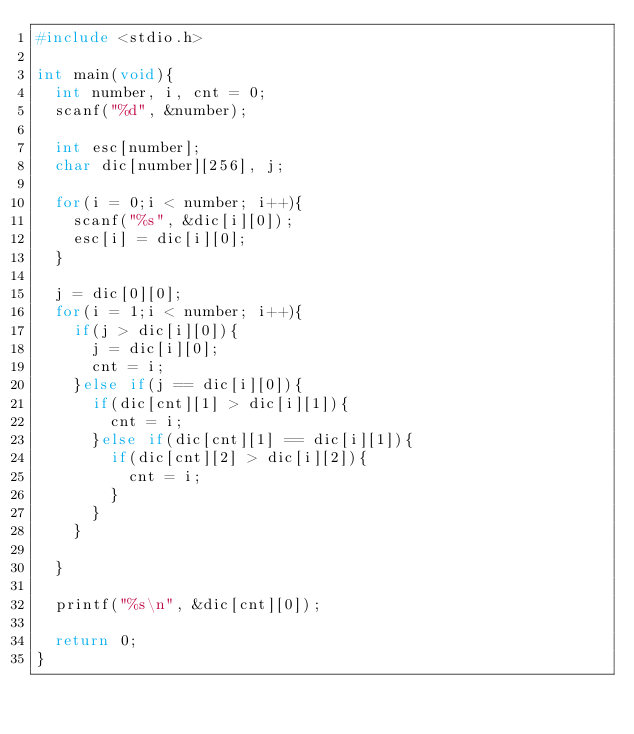Convert code to text. <code><loc_0><loc_0><loc_500><loc_500><_C_>#include <stdio.h>

int main(void){
	int number, i, cnt = 0;
	scanf("%d", &number);

	int esc[number];
	char dic[number][256], j;

	for(i = 0;i < number; i++){
		scanf("%s", &dic[i][0]);
		esc[i] = dic[i][0];
	}

	j = dic[0][0];
	for(i = 1;i < number; i++){
		if(j > dic[i][0]){
			j = dic[i][0];
			cnt = i;
		}else if(j == dic[i][0]){
			if(dic[cnt][1] > dic[i][1]){
				cnt = i;
			}else if(dic[cnt][1] == dic[i][1]){
				if(dic[cnt][2] > dic[i][2]){
					cnt = i;
				}
			}
		}

	}

	printf("%s\n", &dic[cnt][0]);

	return 0;
}</code> 